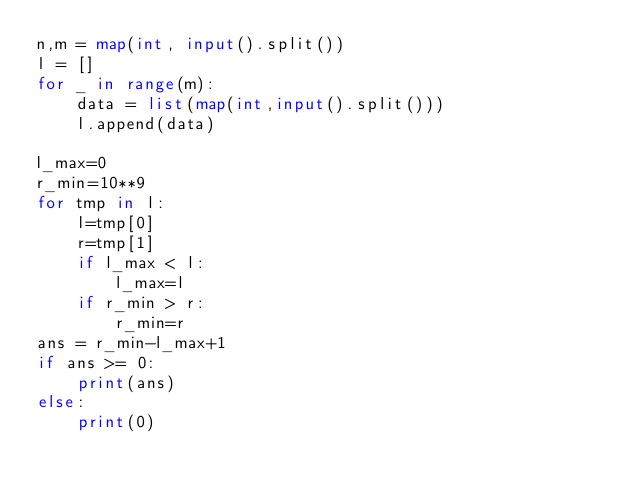Convert code to text. <code><loc_0><loc_0><loc_500><loc_500><_Python_>n,m = map(int, input().split())
l = []
for _ in range(m):
    data = list(map(int,input().split()))
    l.append(data)

l_max=0
r_min=10**9
for tmp in l:
    l=tmp[0]
    r=tmp[1]
    if l_max < l:
        l_max=l
    if r_min > r:
        r_min=r
ans = r_min-l_max+1
if ans >= 0:
    print(ans)
else:
    print(0)</code> 